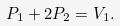Convert formula to latex. <formula><loc_0><loc_0><loc_500><loc_500>P _ { 1 } + 2 P _ { 2 } = V _ { 1 } .</formula> 